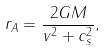<formula> <loc_0><loc_0><loc_500><loc_500>r _ { A } = \frac { 2 G M } { v ^ { 2 } + c _ { s } ^ { 2 } } ,</formula> 